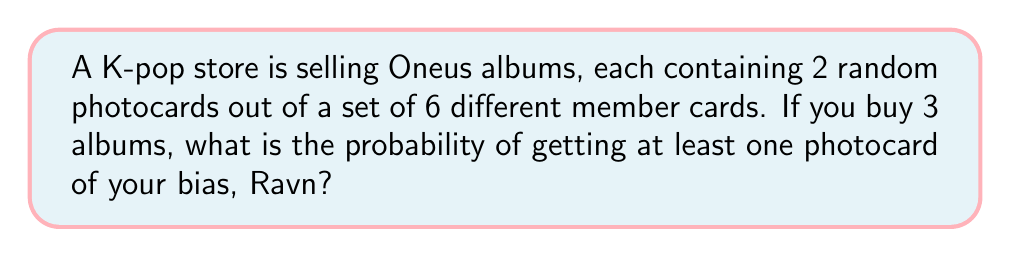Provide a solution to this math problem. Let's approach this step-by-step:

1) First, let's calculate the probability of not getting a Ravn photocard in a single album:
   
   $$P(\text{no Ravn in 1 album}) = \frac{\binom{5}{2}}{\binom{6}{2}} = \frac{10}{15} = \frac{2}{3}$$

2) For 3 albums, the probability of not getting any Ravn photocard is:
   
   $$P(\text{no Ravn in 3 albums}) = \left(\frac{2}{3}\right)^3 = \frac{8}{27}$$

3) Therefore, the probability of getting at least one Ravn photocard is:
   
   $$P(\text{at least one Ravn}) = 1 - P(\text{no Ravn in 3 albums})$$
   
   $$= 1 - \frac{8}{27} = \frac{19}{27}$$

4) To convert to a percentage:
   
   $$\frac{19}{27} \approx 0.7037 = 70.37\%$$
Answer: $\frac{19}{27}$ or approximately 70.37% 